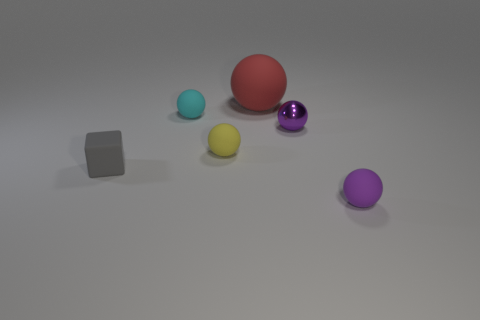Subtract 1 spheres. How many spheres are left? 4 Subtract all purple metallic balls. How many balls are left? 4 Add 4 tiny matte cylinders. How many objects exist? 10 Subtract all cubes. How many objects are left? 5 Add 5 tiny cyan rubber objects. How many tiny cyan rubber objects are left? 6 Add 4 small objects. How many small objects exist? 9 Subtract 1 gray cubes. How many objects are left? 5 Subtract all small gray blocks. Subtract all tiny yellow matte balls. How many objects are left? 4 